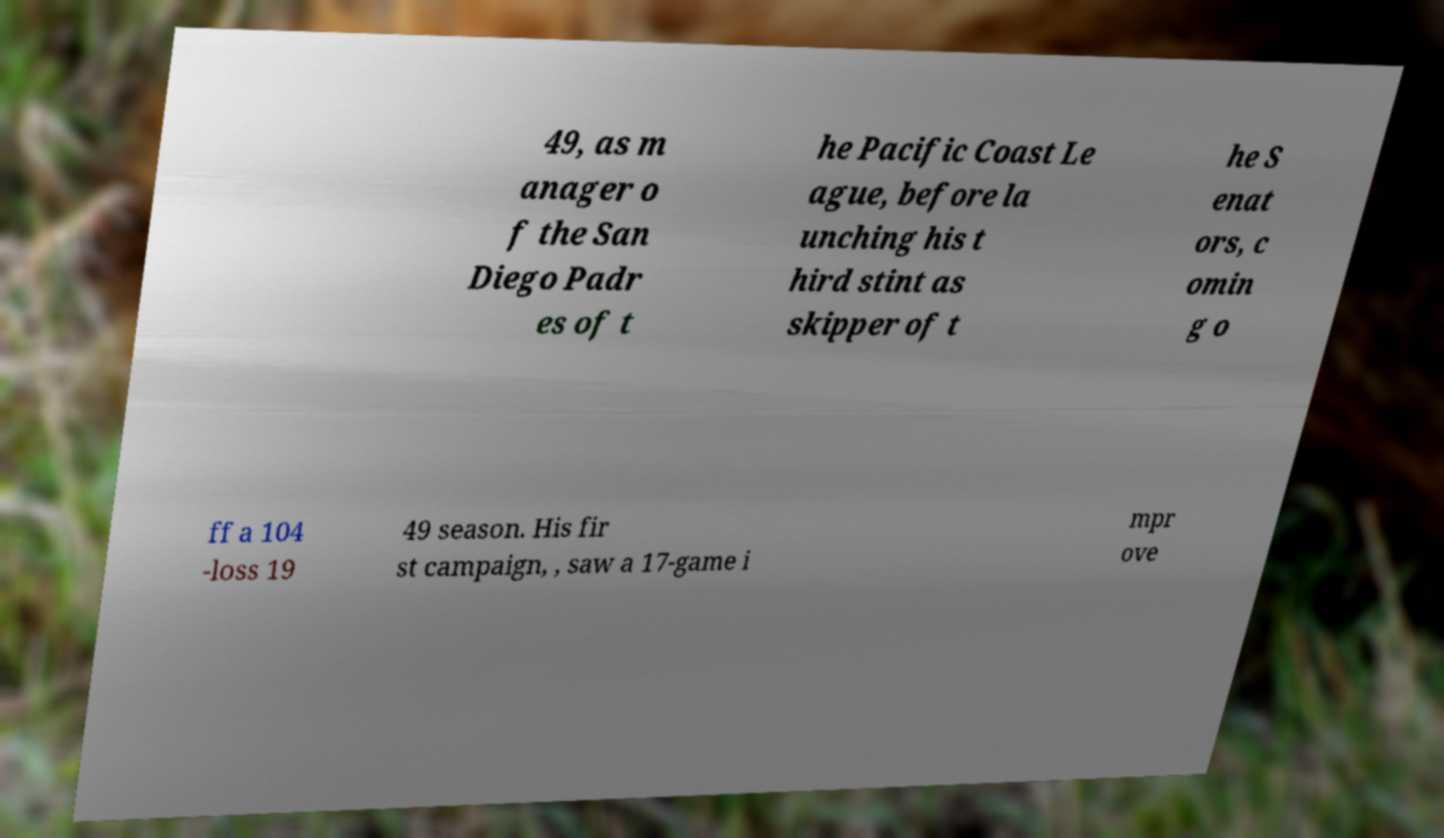I need the written content from this picture converted into text. Can you do that? 49, as m anager o f the San Diego Padr es of t he Pacific Coast Le ague, before la unching his t hird stint as skipper of t he S enat ors, c omin g o ff a 104 -loss 19 49 season. His fir st campaign, , saw a 17-game i mpr ove 